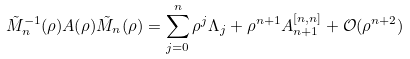<formula> <loc_0><loc_0><loc_500><loc_500>\tilde { M } _ { n } ^ { - 1 } ( \rho ) A ( \rho ) \tilde { M } _ { n } ( \rho ) = \sum _ { j = 0 } ^ { n } \rho ^ { j } \Lambda _ { j } + \rho ^ { n + 1 } A ^ { [ n , n ] } _ { n + 1 } + \mathcal { O } ( \rho ^ { n + 2 } )</formula> 